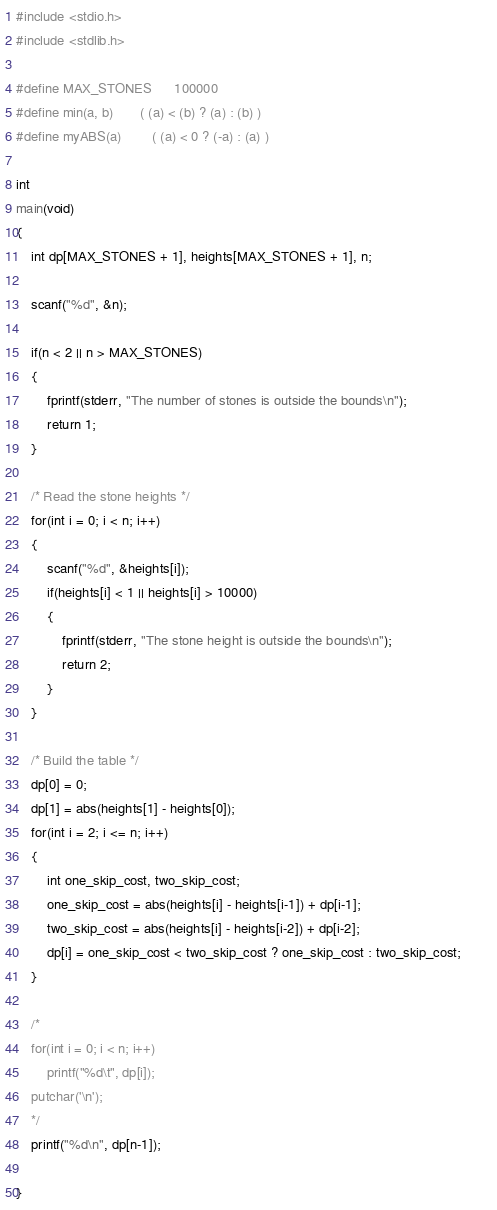<code> <loc_0><loc_0><loc_500><loc_500><_C_>#include <stdio.h>
#include <stdlib.h>

#define MAX_STONES      100000
#define min(a, b)       ( (a) < (b) ? (a) : (b) )
#define myABS(a)        ( (a) < 0 ? (-a) : (a) )

int
main(void)
{
    int dp[MAX_STONES + 1], heights[MAX_STONES + 1], n;

    scanf("%d", &n);
    
    if(n < 2 || n > MAX_STONES)
    {
        fprintf(stderr, "The number of stones is outside the bounds\n");
        return 1;
    }

    /* Read the stone heights */
    for(int i = 0; i < n; i++)
    {
        scanf("%d", &heights[i]);
        if(heights[i] < 1 || heights[i] > 10000)
        {
            fprintf(stderr, "The stone height is outside the bounds\n");
            return 2;
        }
    }

    /* Build the table */
    dp[0] = 0;
    dp[1] = abs(heights[1] - heights[0]);
    for(int i = 2; i <= n; i++)
    {
        int one_skip_cost, two_skip_cost;
        one_skip_cost = abs(heights[i] - heights[i-1]) + dp[i-1];
        two_skip_cost = abs(heights[i] - heights[i-2]) + dp[i-2];
        dp[i] = one_skip_cost < two_skip_cost ? one_skip_cost : two_skip_cost;        
    }

    /*
    for(int i = 0; i < n; i++)
        printf("%d\t", dp[i]);
    putchar('\n');
    */
    printf("%d\n", dp[n-1]);

}
</code> 